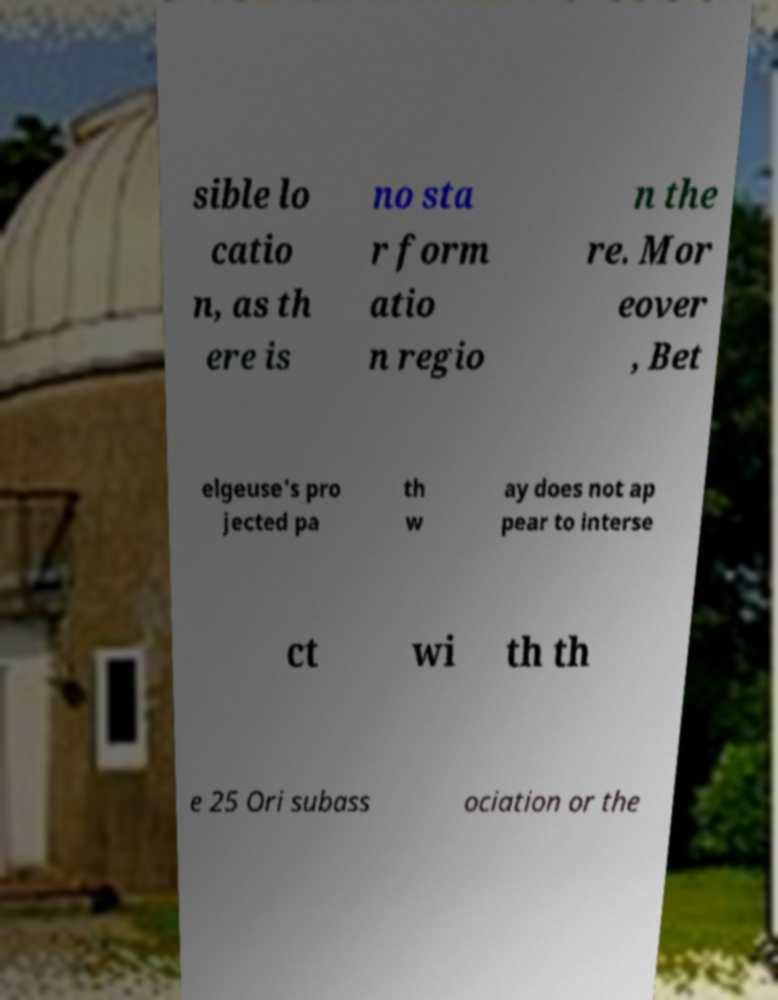There's text embedded in this image that I need extracted. Can you transcribe it verbatim? sible lo catio n, as th ere is no sta r form atio n regio n the re. Mor eover , Bet elgeuse's pro jected pa th w ay does not ap pear to interse ct wi th th e 25 Ori subass ociation or the 